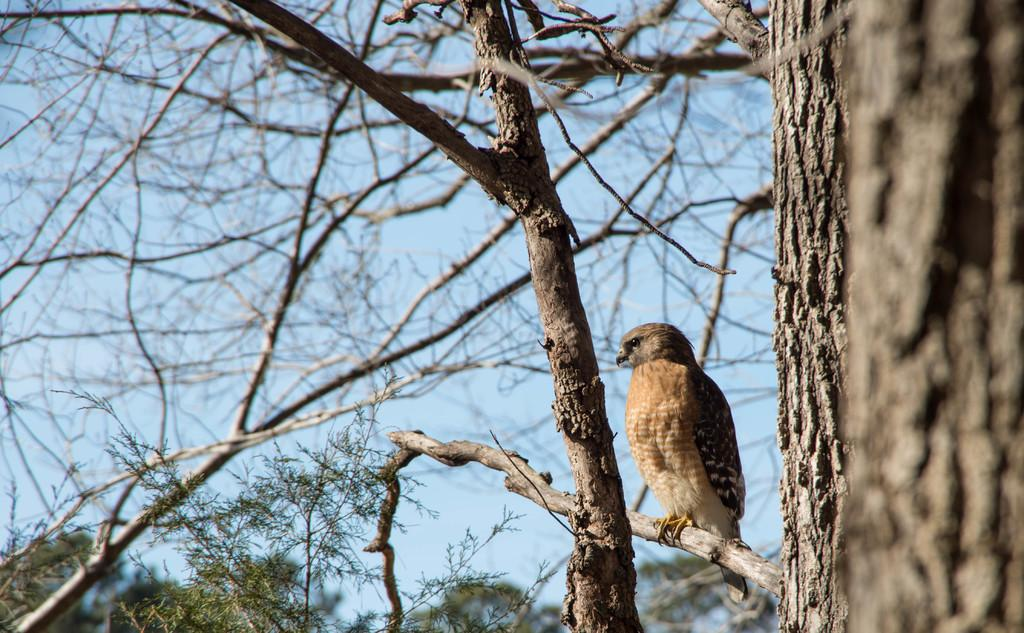What type of animal is in the image? There is a bird in the image. Where is the bird located? The bird is sitting on a tree. What can be seen in the background of the image? There are trees and the sky visible in the background of the image. What type of fruit is the bird holding in its beak in the image? There is no fruit visible in the image, and the bird is not holding anything in its beak. 